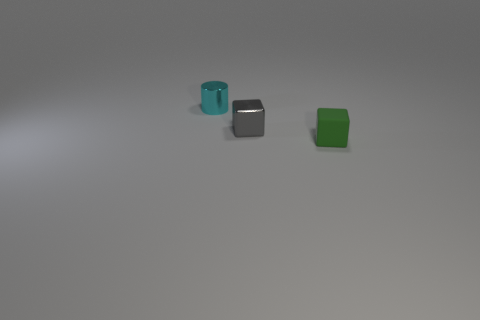Add 1 small gray cubes. How many objects exist? 4 Subtract all cylinders. How many objects are left? 2 Add 2 tiny green blocks. How many tiny green blocks exist? 3 Subtract 0 red cylinders. How many objects are left? 3 Subtract all tiny cyan matte balls. Subtract all tiny rubber things. How many objects are left? 2 Add 1 cyan objects. How many cyan objects are left? 2 